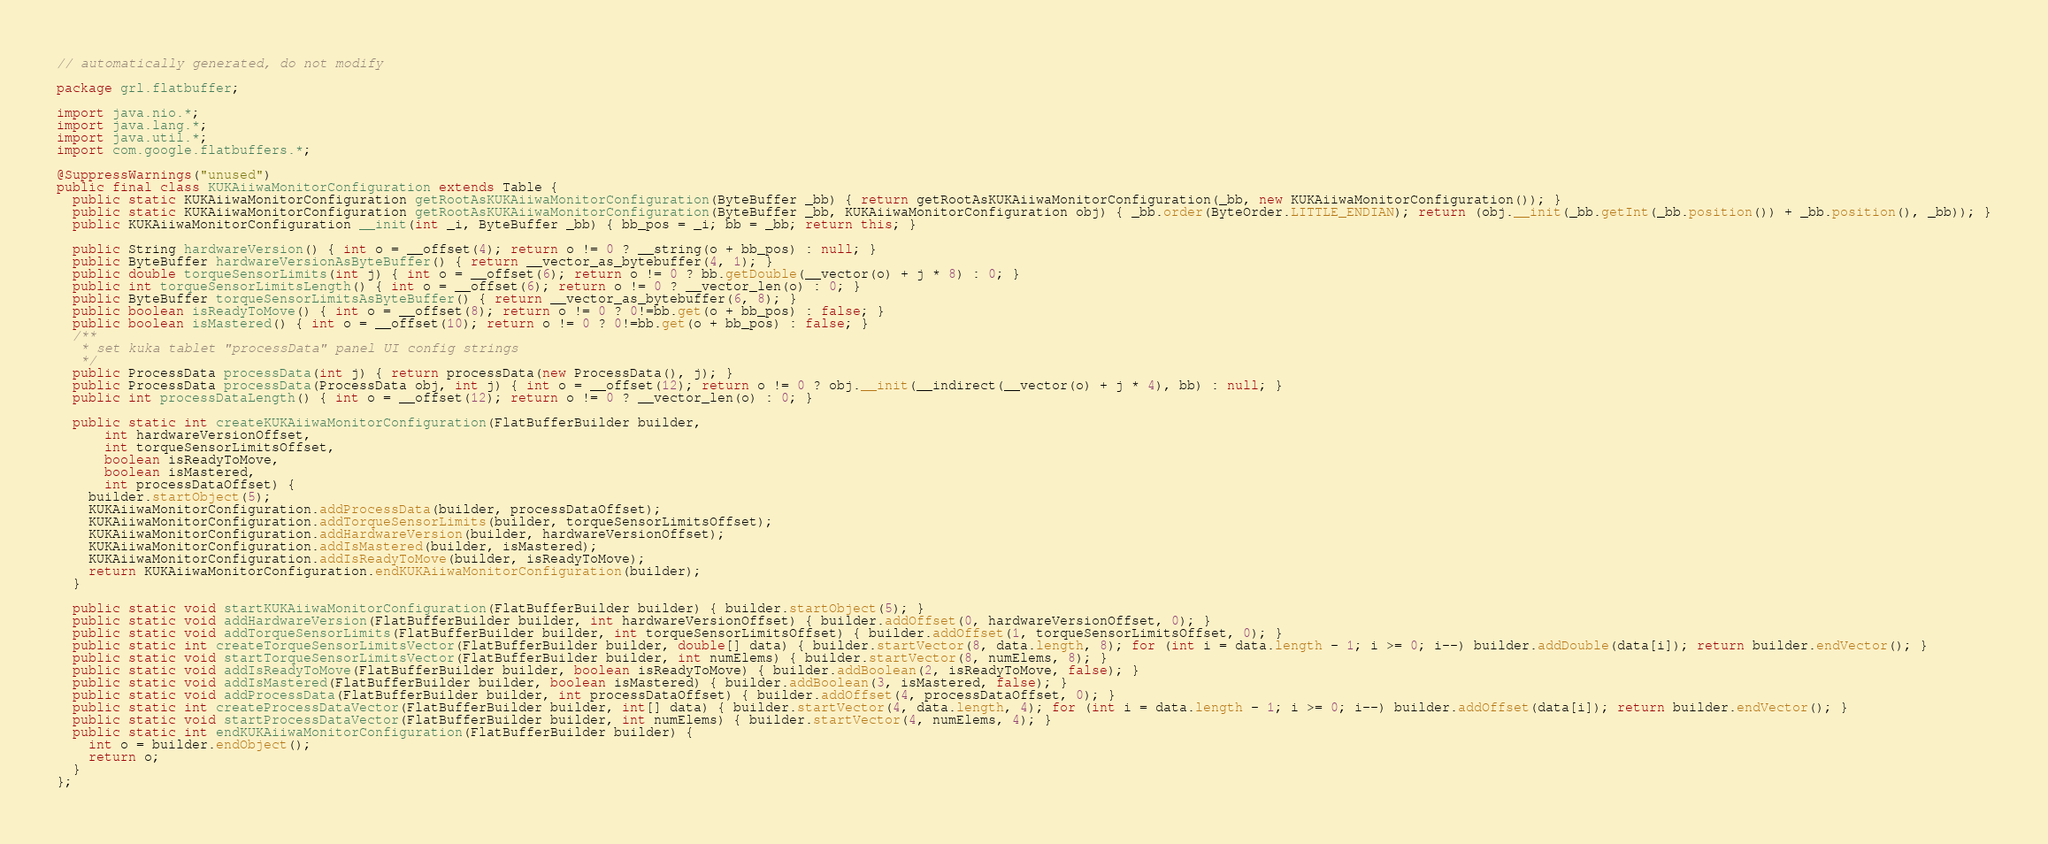Convert code to text. <code><loc_0><loc_0><loc_500><loc_500><_Java_>// automatically generated, do not modify

package grl.flatbuffer;

import java.nio.*;
import java.lang.*;
import java.util.*;
import com.google.flatbuffers.*;

@SuppressWarnings("unused")
public final class KUKAiiwaMonitorConfiguration extends Table {
  public static KUKAiiwaMonitorConfiguration getRootAsKUKAiiwaMonitorConfiguration(ByteBuffer _bb) { return getRootAsKUKAiiwaMonitorConfiguration(_bb, new KUKAiiwaMonitorConfiguration()); }
  public static KUKAiiwaMonitorConfiguration getRootAsKUKAiiwaMonitorConfiguration(ByteBuffer _bb, KUKAiiwaMonitorConfiguration obj) { _bb.order(ByteOrder.LITTLE_ENDIAN); return (obj.__init(_bb.getInt(_bb.position()) + _bb.position(), _bb)); }
  public KUKAiiwaMonitorConfiguration __init(int _i, ByteBuffer _bb) { bb_pos = _i; bb = _bb; return this; }

  public String hardwareVersion() { int o = __offset(4); return o != 0 ? __string(o + bb_pos) : null; }
  public ByteBuffer hardwareVersionAsByteBuffer() { return __vector_as_bytebuffer(4, 1); }
  public double torqueSensorLimits(int j) { int o = __offset(6); return o != 0 ? bb.getDouble(__vector(o) + j * 8) : 0; }
  public int torqueSensorLimitsLength() { int o = __offset(6); return o != 0 ? __vector_len(o) : 0; }
  public ByteBuffer torqueSensorLimitsAsByteBuffer() { return __vector_as_bytebuffer(6, 8); }
  public boolean isReadyToMove() { int o = __offset(8); return o != 0 ? 0!=bb.get(o + bb_pos) : false; }
  public boolean isMastered() { int o = __offset(10); return o != 0 ? 0!=bb.get(o + bb_pos) : false; }
  /**
   * set kuka tablet "processData" panel UI config strings
   */
  public ProcessData processData(int j) { return processData(new ProcessData(), j); }
  public ProcessData processData(ProcessData obj, int j) { int o = __offset(12); return o != 0 ? obj.__init(__indirect(__vector(o) + j * 4), bb) : null; }
  public int processDataLength() { int o = __offset(12); return o != 0 ? __vector_len(o) : 0; }

  public static int createKUKAiiwaMonitorConfiguration(FlatBufferBuilder builder,
      int hardwareVersionOffset,
      int torqueSensorLimitsOffset,
      boolean isReadyToMove,
      boolean isMastered,
      int processDataOffset) {
    builder.startObject(5);
    KUKAiiwaMonitorConfiguration.addProcessData(builder, processDataOffset);
    KUKAiiwaMonitorConfiguration.addTorqueSensorLimits(builder, torqueSensorLimitsOffset);
    KUKAiiwaMonitorConfiguration.addHardwareVersion(builder, hardwareVersionOffset);
    KUKAiiwaMonitorConfiguration.addIsMastered(builder, isMastered);
    KUKAiiwaMonitorConfiguration.addIsReadyToMove(builder, isReadyToMove);
    return KUKAiiwaMonitorConfiguration.endKUKAiiwaMonitorConfiguration(builder);
  }

  public static void startKUKAiiwaMonitorConfiguration(FlatBufferBuilder builder) { builder.startObject(5); }
  public static void addHardwareVersion(FlatBufferBuilder builder, int hardwareVersionOffset) { builder.addOffset(0, hardwareVersionOffset, 0); }
  public static void addTorqueSensorLimits(FlatBufferBuilder builder, int torqueSensorLimitsOffset) { builder.addOffset(1, torqueSensorLimitsOffset, 0); }
  public static int createTorqueSensorLimitsVector(FlatBufferBuilder builder, double[] data) { builder.startVector(8, data.length, 8); for (int i = data.length - 1; i >= 0; i--) builder.addDouble(data[i]); return builder.endVector(); }
  public static void startTorqueSensorLimitsVector(FlatBufferBuilder builder, int numElems) { builder.startVector(8, numElems, 8); }
  public static void addIsReadyToMove(FlatBufferBuilder builder, boolean isReadyToMove) { builder.addBoolean(2, isReadyToMove, false); }
  public static void addIsMastered(FlatBufferBuilder builder, boolean isMastered) { builder.addBoolean(3, isMastered, false); }
  public static void addProcessData(FlatBufferBuilder builder, int processDataOffset) { builder.addOffset(4, processDataOffset, 0); }
  public static int createProcessDataVector(FlatBufferBuilder builder, int[] data) { builder.startVector(4, data.length, 4); for (int i = data.length - 1; i >= 0; i--) builder.addOffset(data[i]); return builder.endVector(); }
  public static void startProcessDataVector(FlatBufferBuilder builder, int numElems) { builder.startVector(4, numElems, 4); }
  public static int endKUKAiiwaMonitorConfiguration(FlatBufferBuilder builder) {
    int o = builder.endObject();
    return o;
  }
};

</code> 